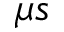Convert formula to latex. <formula><loc_0><loc_0><loc_500><loc_500>\mu s</formula> 